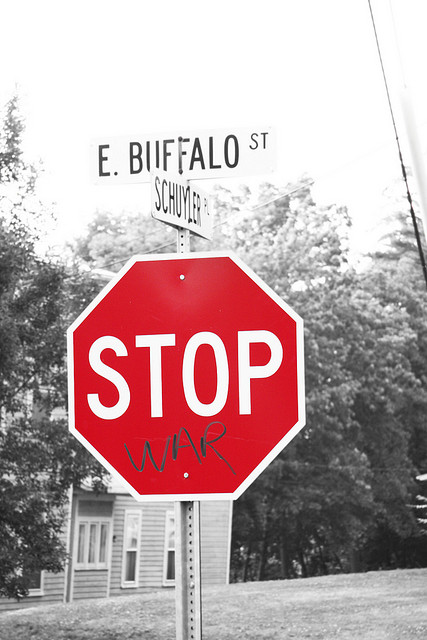Identify and read out the text in this image. E.BUFFALO ST SCHUYLER STOP WAR 